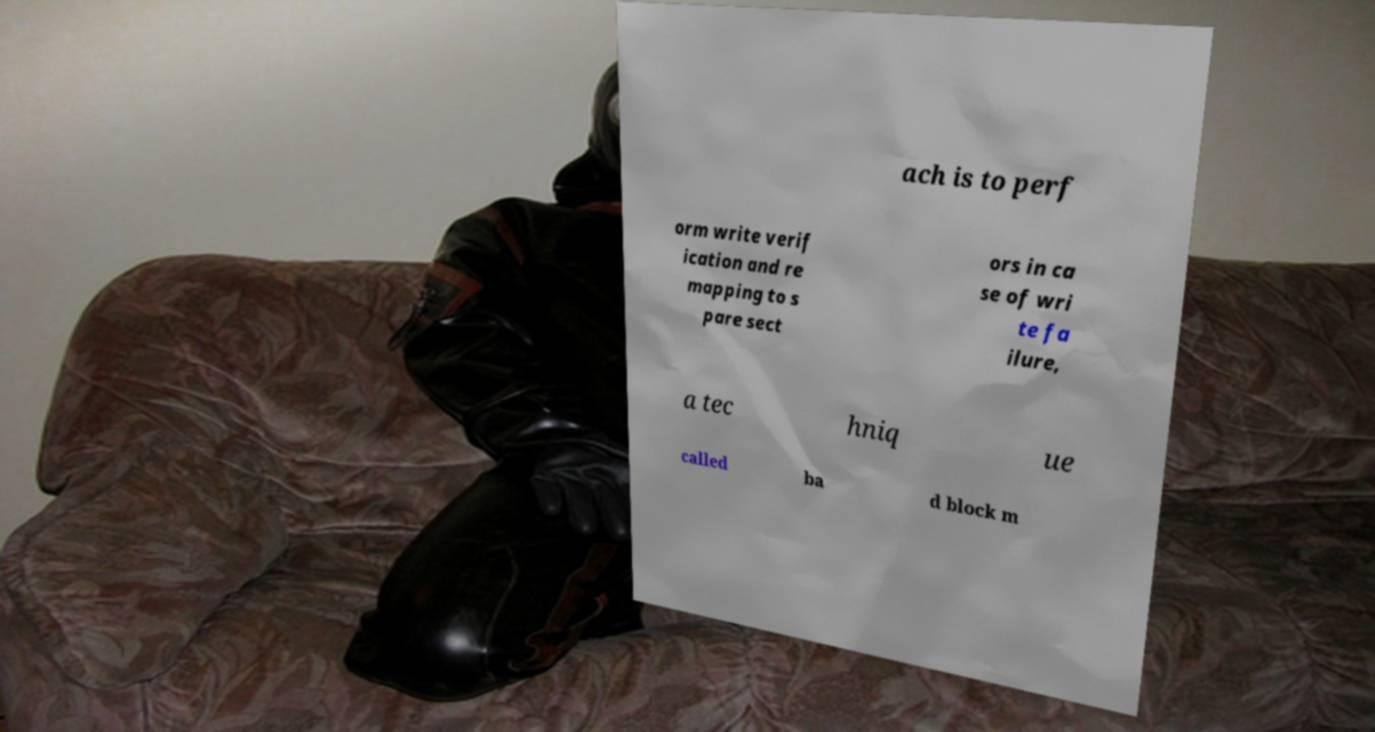What messages or text are displayed in this image? I need them in a readable, typed format. ach is to perf orm write verif ication and re mapping to s pare sect ors in ca se of wri te fa ilure, a tec hniq ue called ba d block m 